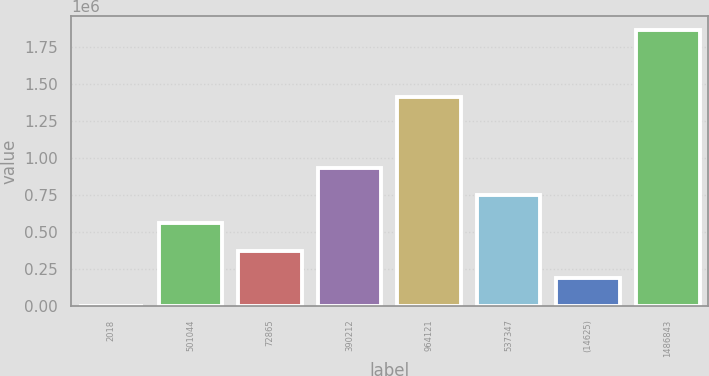<chart> <loc_0><loc_0><loc_500><loc_500><bar_chart><fcel>2018<fcel>501044<fcel>72865<fcel>390212<fcel>964121<fcel>537347<fcel>(14625)<fcel>1486843<nl><fcel>2017<fcel>560636<fcel>374430<fcel>933050<fcel>1.40996e+06<fcel>746843<fcel>188224<fcel>1.86408e+06<nl></chart> 